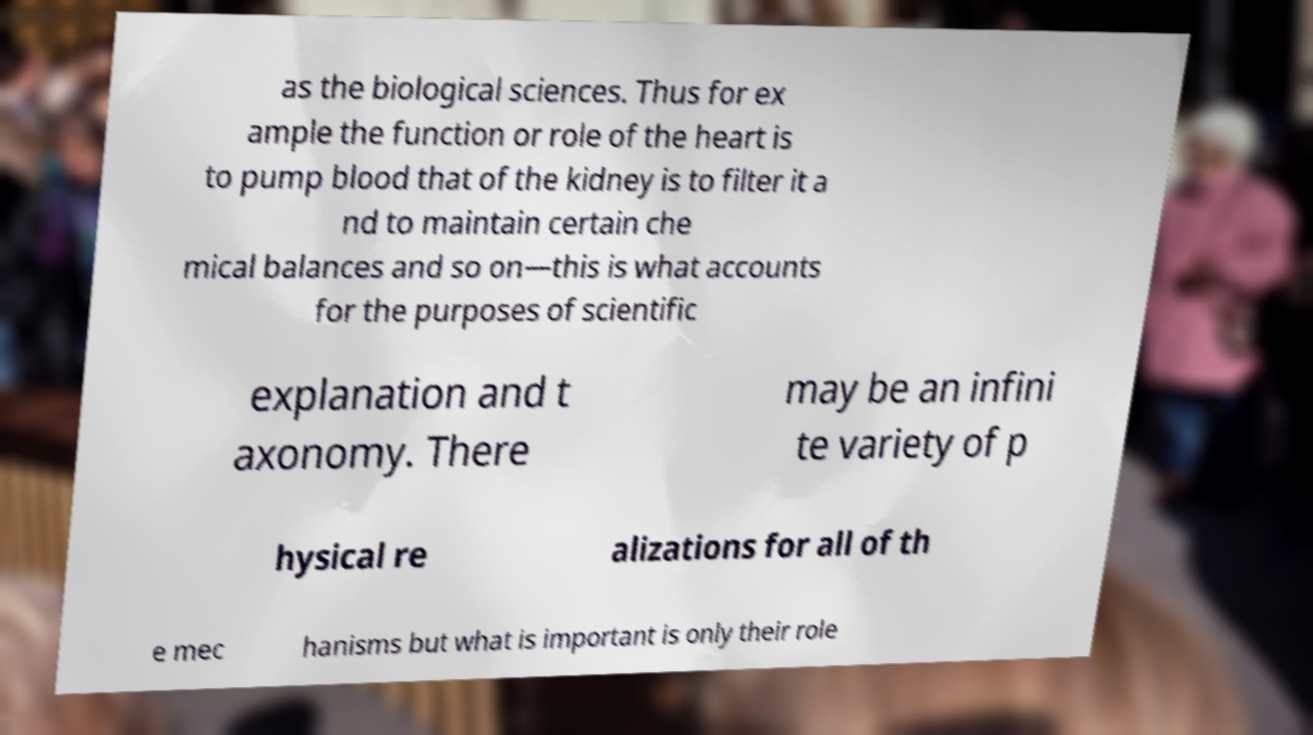I need the written content from this picture converted into text. Can you do that? as the biological sciences. Thus for ex ample the function or role of the heart is to pump blood that of the kidney is to filter it a nd to maintain certain che mical balances and so on—this is what accounts for the purposes of scientific explanation and t axonomy. There may be an infini te variety of p hysical re alizations for all of th e mec hanisms but what is important is only their role 